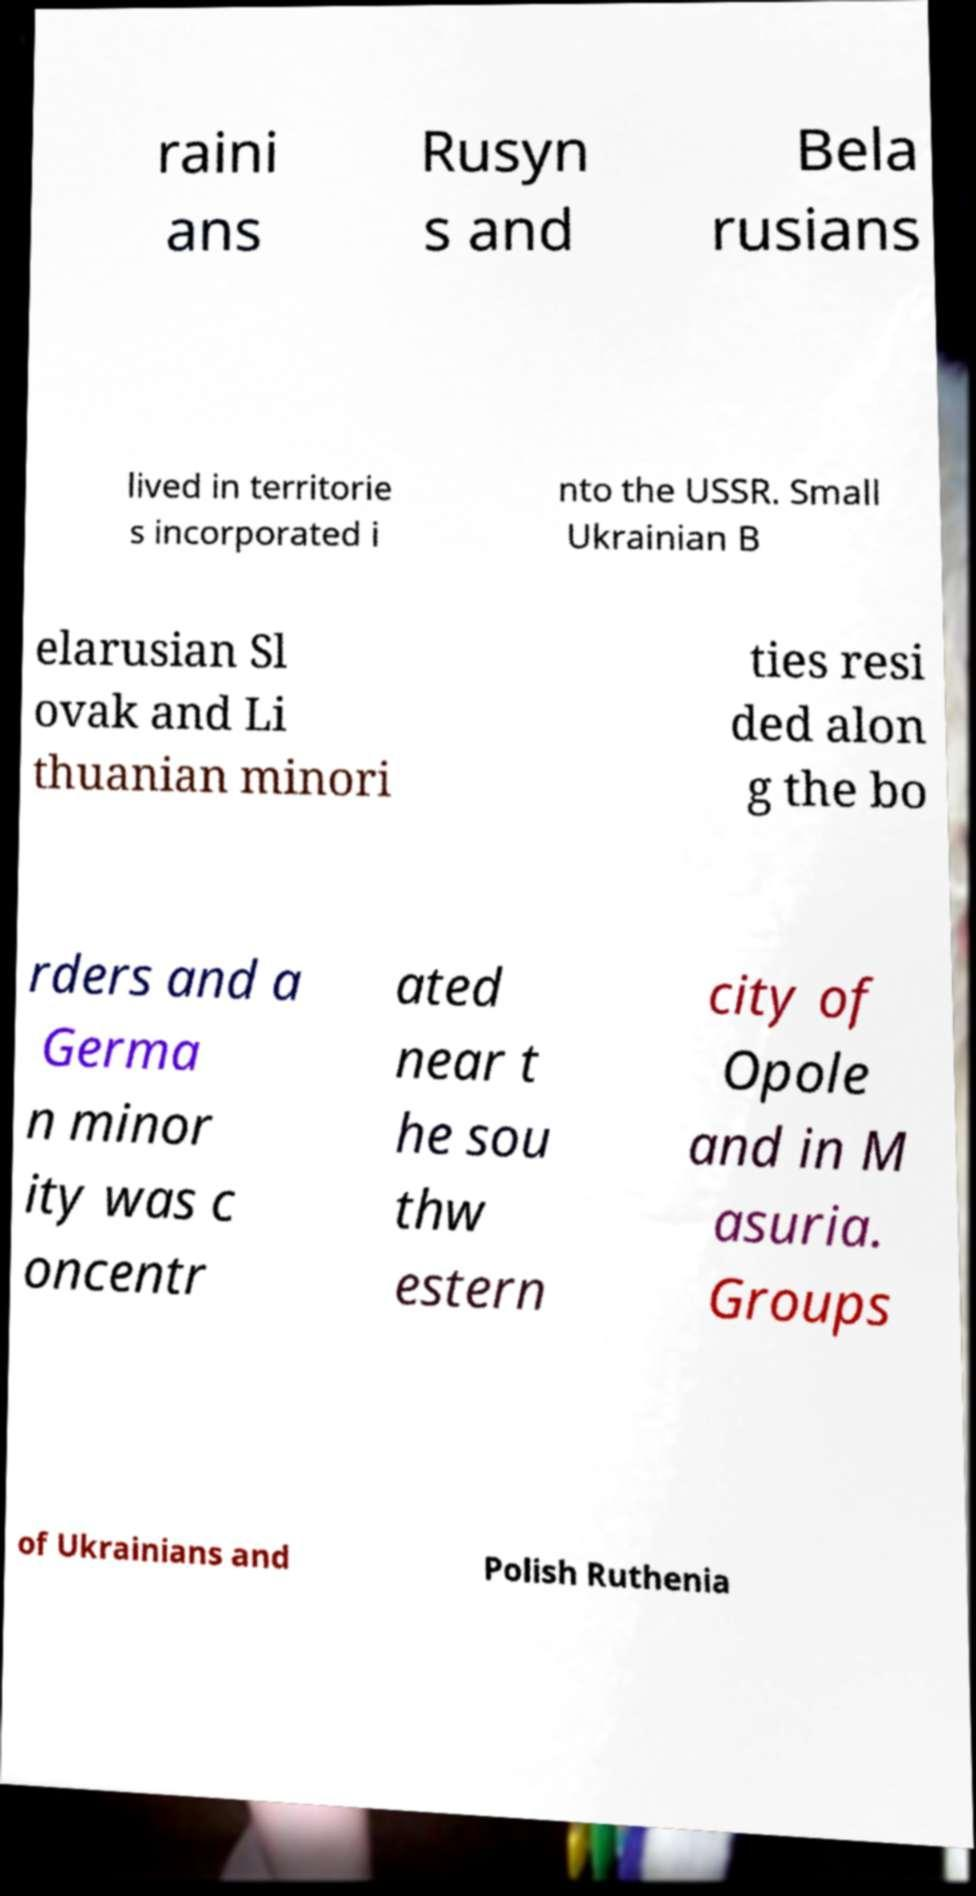There's text embedded in this image that I need extracted. Can you transcribe it verbatim? raini ans Rusyn s and Bela rusians lived in territorie s incorporated i nto the USSR. Small Ukrainian B elarusian Sl ovak and Li thuanian minori ties resi ded alon g the bo rders and a Germa n minor ity was c oncentr ated near t he sou thw estern city of Opole and in M asuria. Groups of Ukrainians and Polish Ruthenia 